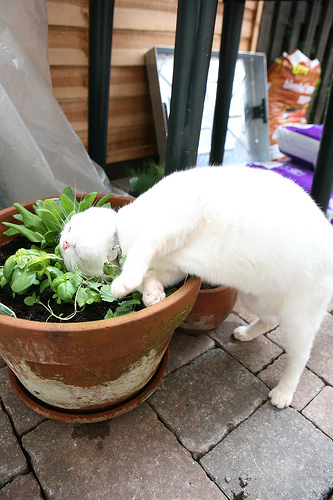Is that pot large or small? The pot in the photo appears to be large. 